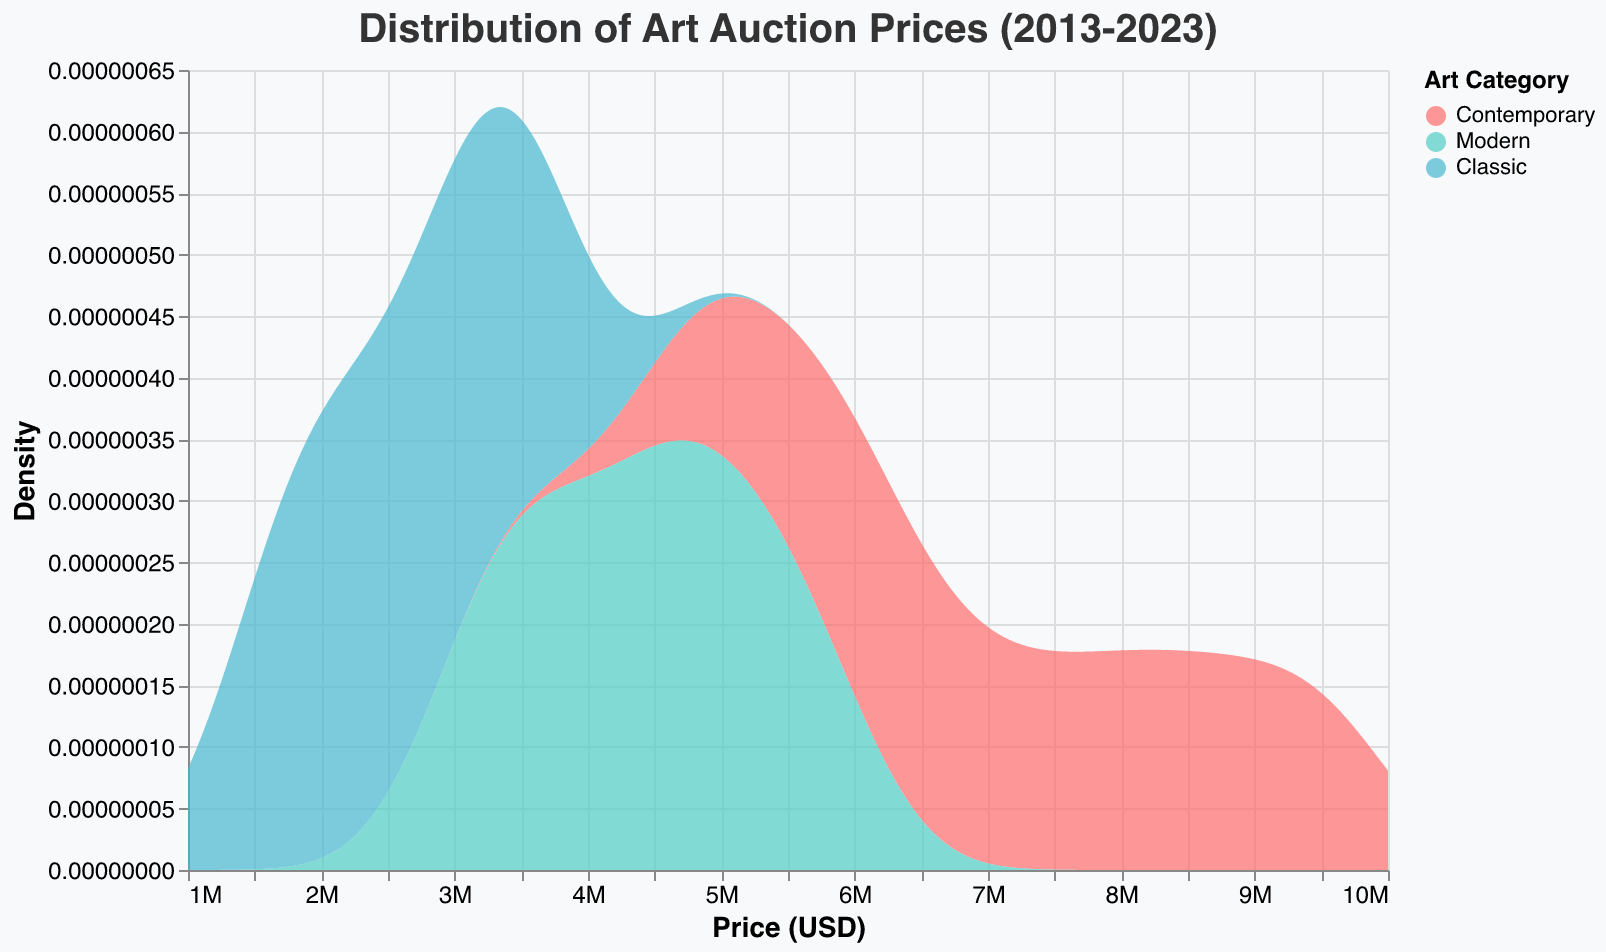What is the title of the plot? The title of the plot is usually found at the top center of the figure. In this case, it clearly states the focus of the plot.
Answer: Distribution of Art Auction Prices (2013-2023) Which category of art has the highest density of auction prices around $9,000,000? By looking at the density peaks, you can see that Contemporary art has the highest density around the $9,000,000 mark, as it reaches the highest at that price point.
Answer: Contemporary art How does the peak density value for Modern art compare with that of Classic art? To compare the peak densities, look at the highest points of the density curves for both Modern and Classic art. Modern art has a visibly higher peak density than Classic art.
Answer: Modern art has a higher peak density What is the approximate price range where Contemporary art shows the highest density? The highest peak for Contemporary art is between $8,000,000 to $10,000,000, identify this by observing where the density curve for Contemporary art reaches its maximum height.
Answer: $8,000,000 to $10,000,000 In which price range do all three categories overlap the most? Observing where the density curves for Contemporary, Modern, and Classic art overlap, the area of most significant overlap is around $3,000,000 to $4,000,000.
Answer: $3,000,000 to $4,000,000 Which category has the narrowest spread of auction prices and how can you tell? The spread can be determined by observing how wide the density curve is. A narrower curve indicates a narrower spread of prices. Classic art has the narrowest spread as its curve is the most concentrated around its central values.
Answer: Classic art What is the general trend in auction prices for Contemporary art over the decade? To determine this, look at the density curve for Contemporary art and note how it shifts to the right over the price axis from 2013 to 2023, indicating increasing prices.
Answer: Increasing trend Between what price ranges does Modern art exhibit a major density peak? Identify the primary peak area by looking at the highest points of the Modern art density curve. It peaks mainly between $5,000,000 and $6,000,000.
Answer: $5,000,000 to $6,000,000 What category of art shows a peak around $2,000,000, and what does this say about its prices? Look for peaks near $2,000,000 on the density curves and see which category touches this range. Classic art shows a peak here, indicating many auction prices are around this value.
Answer: Classic art If you were to invest in a category of art with the least price volatility over the last decade, which would it be? Price volatility corresponds to how spread out the prices are. Looking at the density curves, Classic art with its concentrated peak suggests the least volatility in prices.
Answer: Classic art 